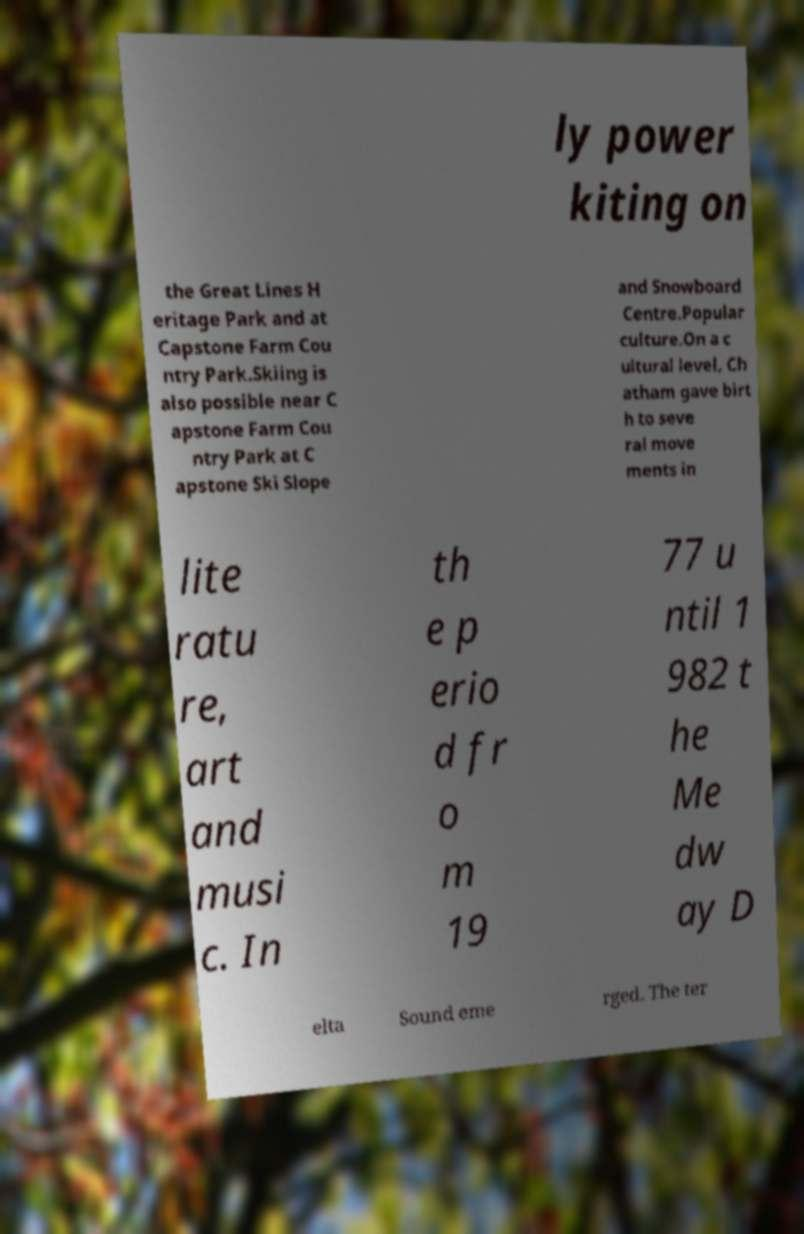For documentation purposes, I need the text within this image transcribed. Could you provide that? ly power kiting on the Great Lines H eritage Park and at Capstone Farm Cou ntry Park.Skiing is also possible near C apstone Farm Cou ntry Park at C apstone Ski Slope and Snowboard Centre.Popular culture.On a c ultural level, Ch atham gave birt h to seve ral move ments in lite ratu re, art and musi c. In th e p erio d fr o m 19 77 u ntil 1 982 t he Me dw ay D elta Sound eme rged. The ter 